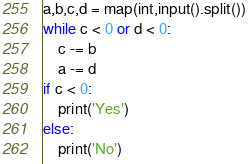Convert code to text. <code><loc_0><loc_0><loc_500><loc_500><_Python_>a,b,c,d = map(int,input().split())
while c < 0 or d < 0:
    c -= b
    a -= d
if c < 0:
    print('Yes')
else:
    print('No')</code> 